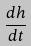Convert formula to latex. <formula><loc_0><loc_0><loc_500><loc_500>\frac { d h } { d t }</formula> 